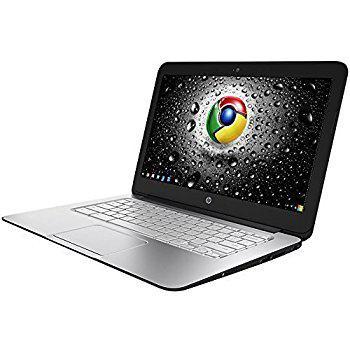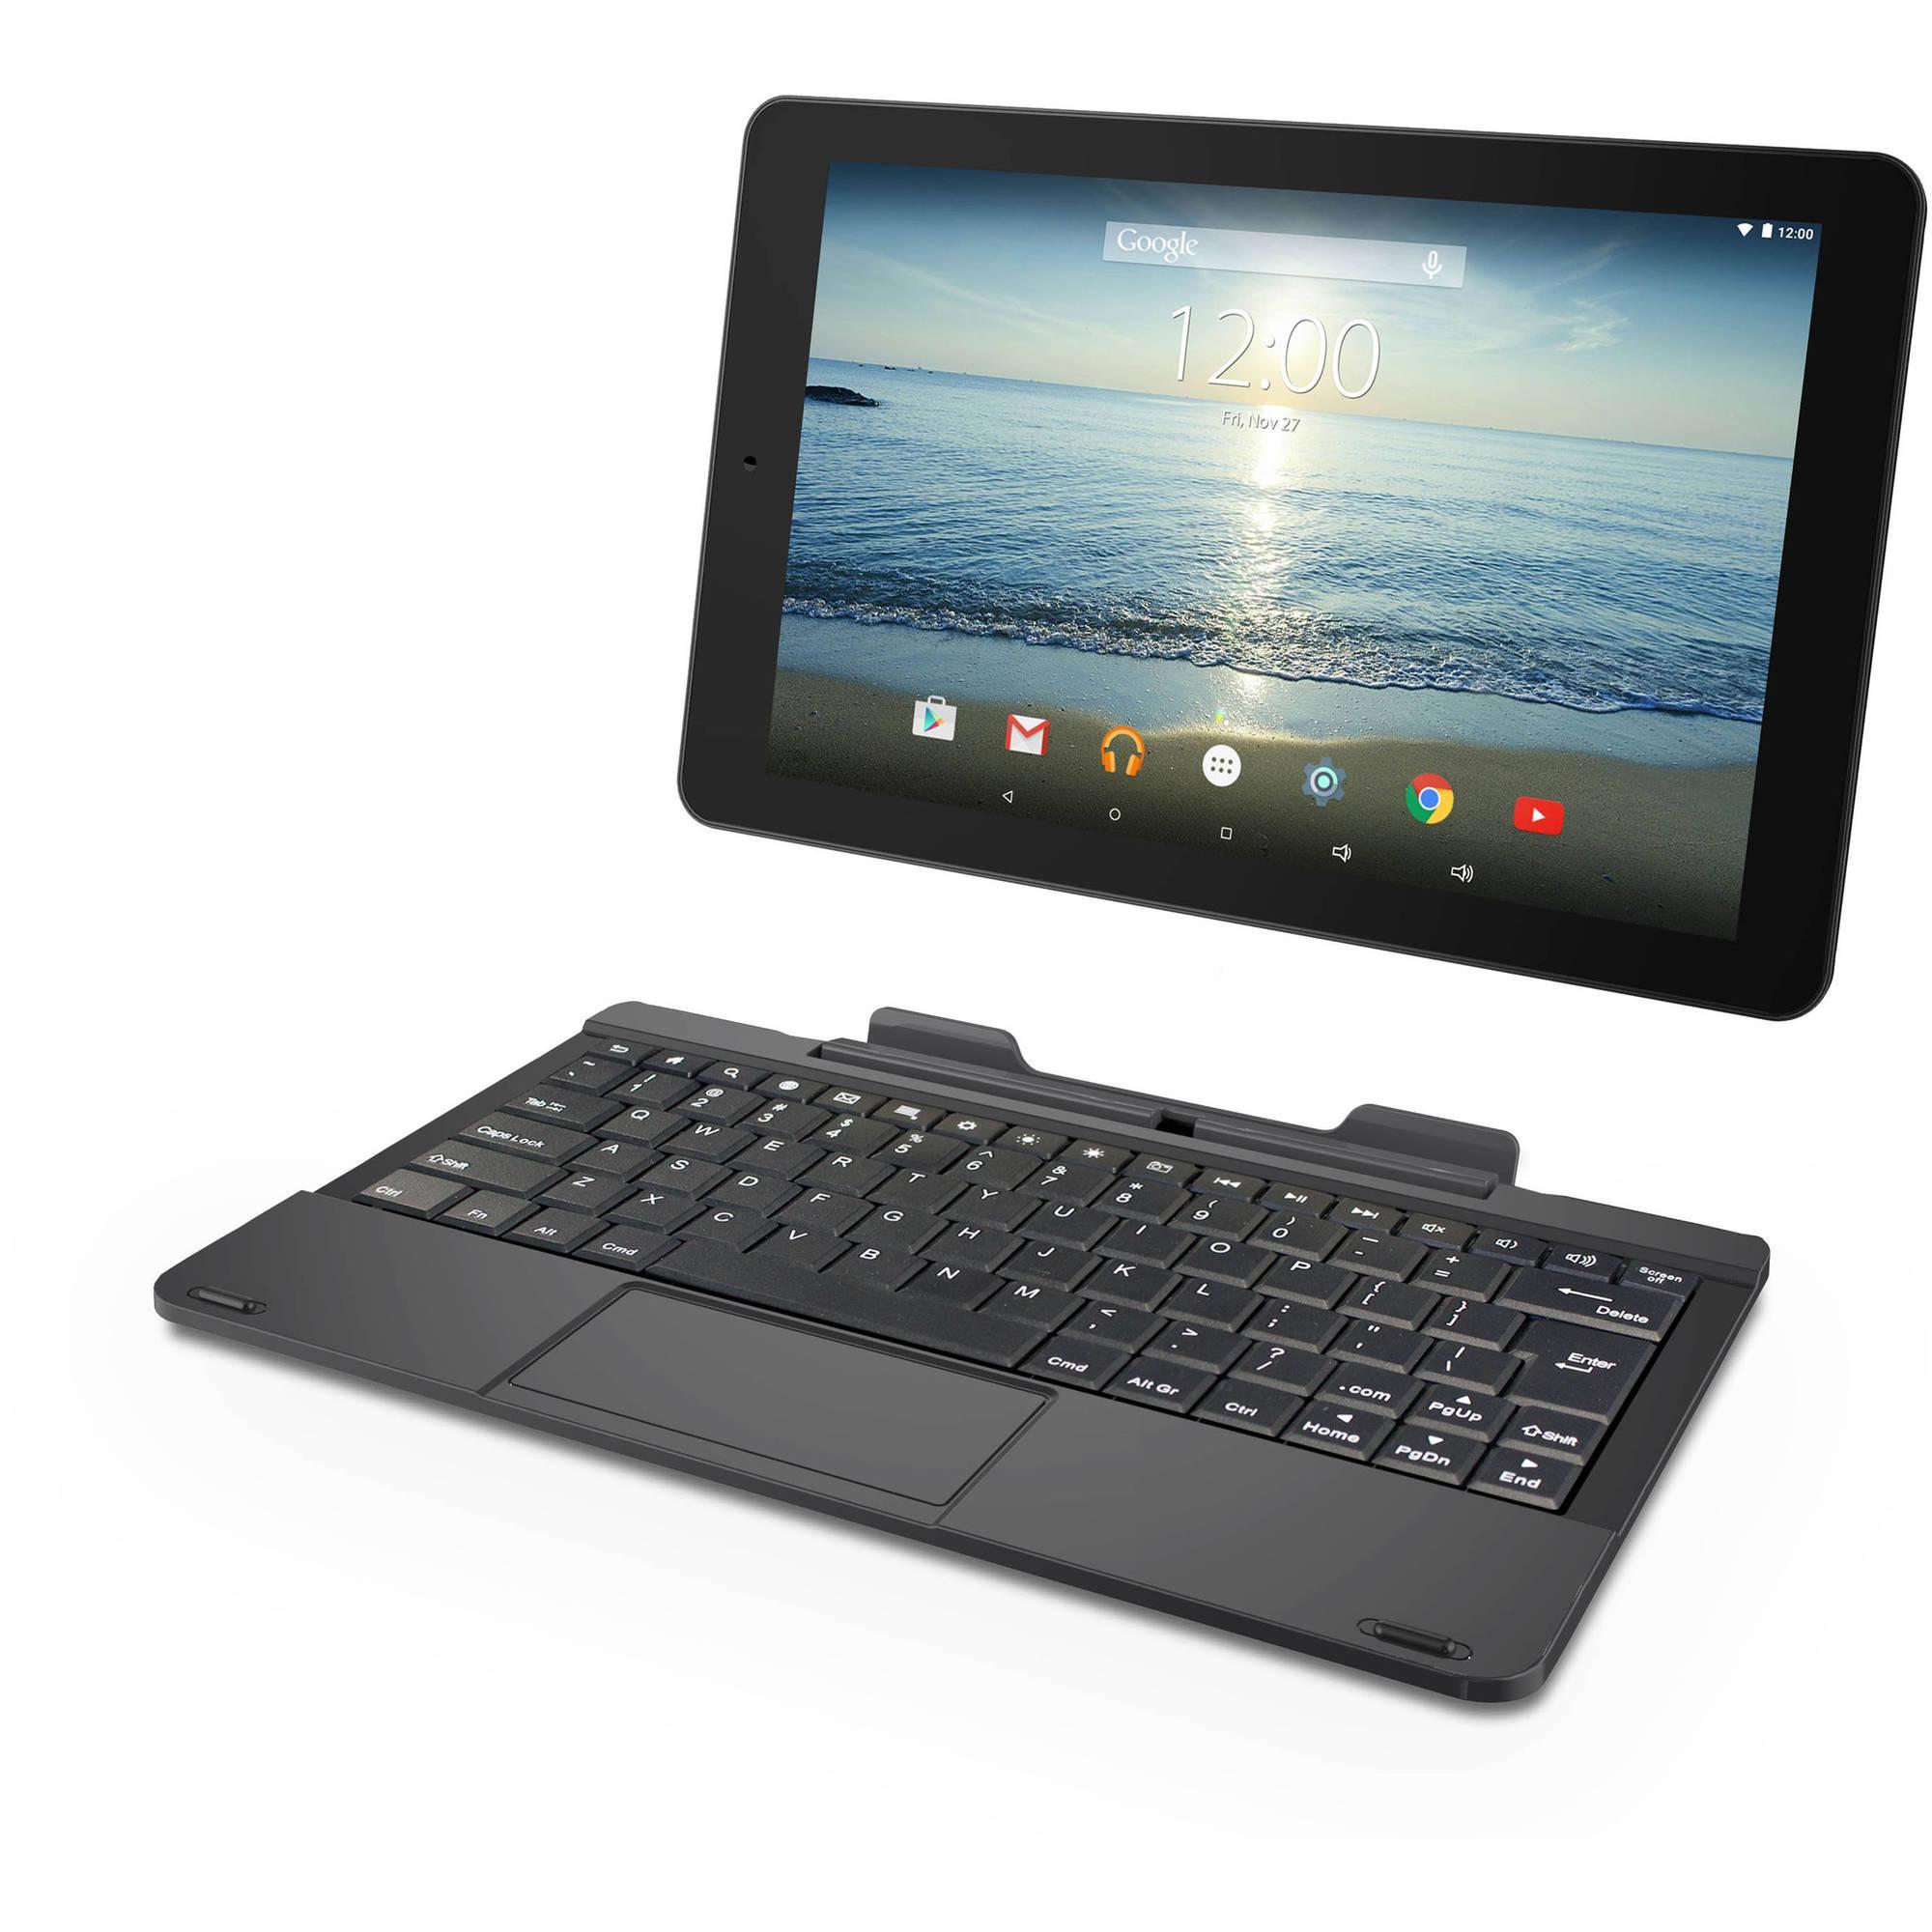The first image is the image on the left, the second image is the image on the right. Assess this claim about the two images: "Each image contains exactly one open laptop, and no laptop screen is disconnected from the base.". Correct or not? Answer yes or no. No. The first image is the image on the left, the second image is the image on the right. Analyze the images presented: Is the assertion "One of the laptops has a blank screen." valid? Answer yes or no. No. 